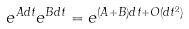Convert formula to latex. <formula><loc_0><loc_0><loc_500><loc_500>e ^ { A d t } e ^ { B d t } = e ^ { ( A + B ) d t + O ( d t ^ { 2 } ) }</formula> 